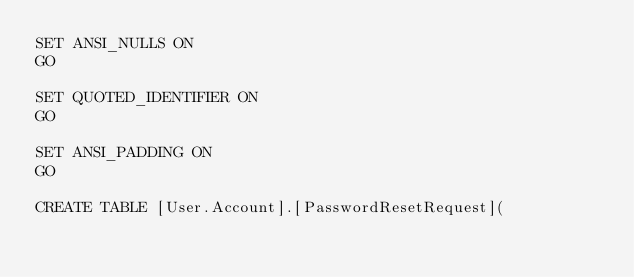<code> <loc_0><loc_0><loc_500><loc_500><_SQL_>SET ANSI_NULLS ON
GO

SET QUOTED_IDENTIFIER ON
GO

SET ANSI_PADDING ON
GO

CREATE TABLE [User.Account].[PasswordResetRequest](</code> 